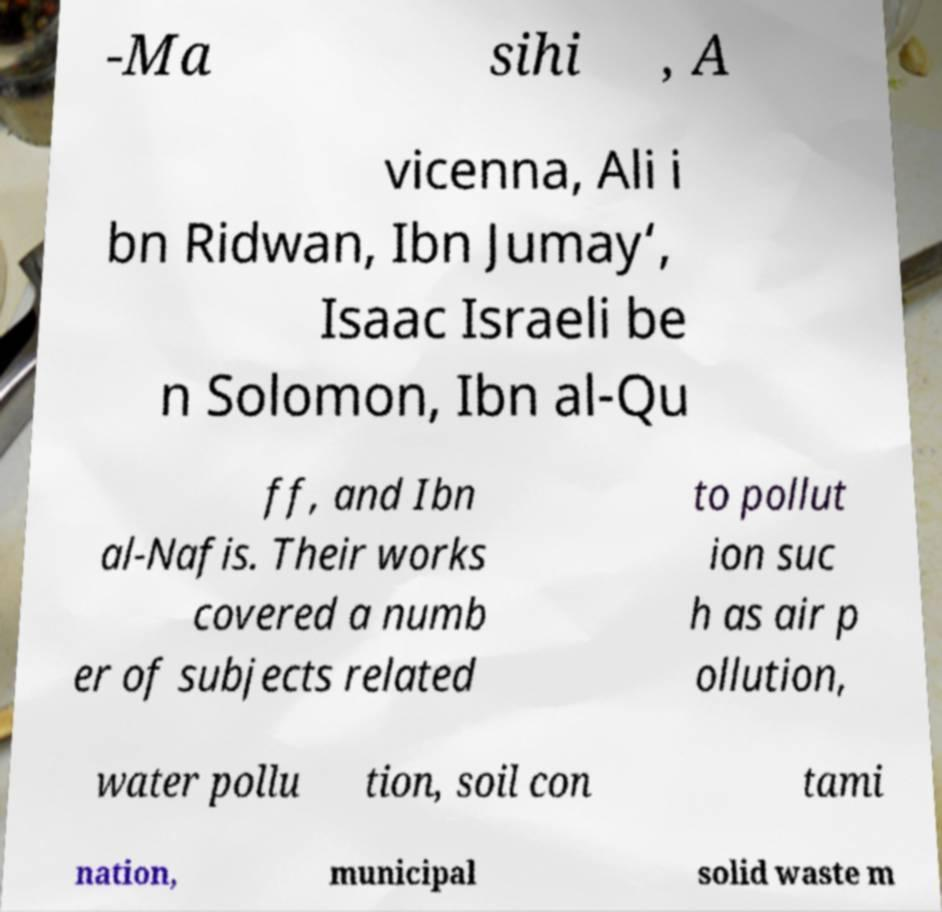Please read and relay the text visible in this image. What does it say? -Ma sihi , A vicenna, Ali i bn Ridwan, Ibn Jumay‘, Isaac Israeli be n Solomon, Ibn al-Qu ff, and Ibn al-Nafis. Their works covered a numb er of subjects related to pollut ion suc h as air p ollution, water pollu tion, soil con tami nation, municipal solid waste m 